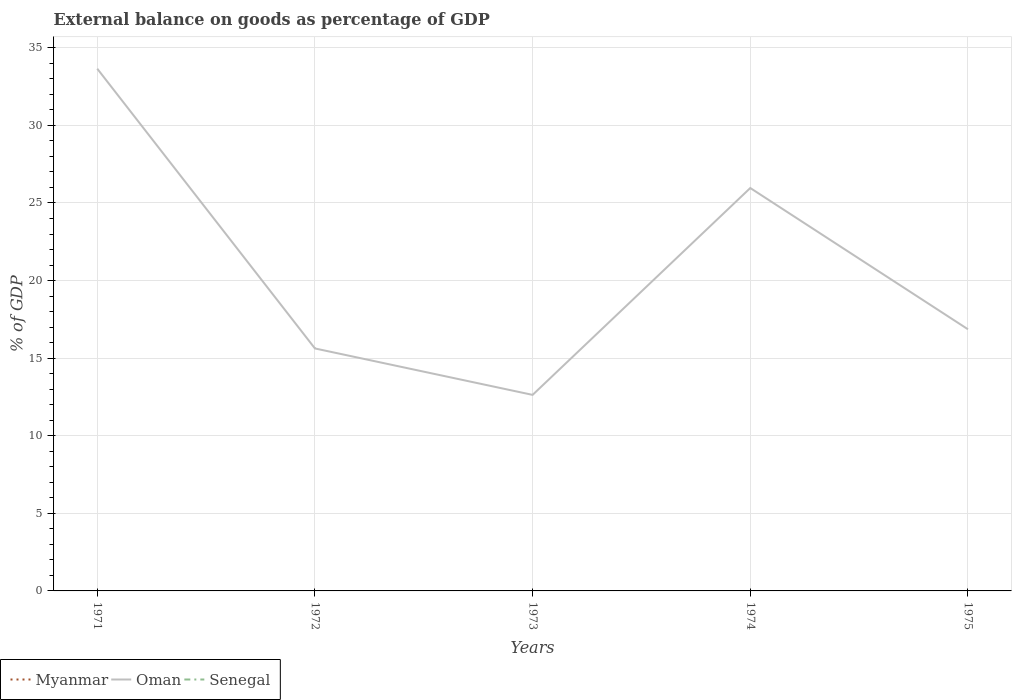How many different coloured lines are there?
Provide a succinct answer. 1. Does the line corresponding to Myanmar intersect with the line corresponding to Senegal?
Your response must be concise. No. Across all years, what is the maximum external balance on goods as percentage of GDP in Senegal?
Ensure brevity in your answer.  0. What is the total external balance on goods as percentage of GDP in Oman in the graph?
Provide a short and direct response. 21.02. What is the difference between the highest and the second highest external balance on goods as percentage of GDP in Oman?
Give a very brief answer. 21.02. What is the difference between the highest and the lowest external balance on goods as percentage of GDP in Oman?
Offer a terse response. 2. Is the external balance on goods as percentage of GDP in Oman strictly greater than the external balance on goods as percentage of GDP in Senegal over the years?
Keep it short and to the point. No. How many years are there in the graph?
Provide a short and direct response. 5. What is the difference between two consecutive major ticks on the Y-axis?
Keep it short and to the point. 5. Are the values on the major ticks of Y-axis written in scientific E-notation?
Keep it short and to the point. No. Does the graph contain any zero values?
Ensure brevity in your answer.  Yes. Does the graph contain grids?
Offer a terse response. Yes. How many legend labels are there?
Give a very brief answer. 3. How are the legend labels stacked?
Your answer should be compact. Horizontal. What is the title of the graph?
Provide a succinct answer. External balance on goods as percentage of GDP. Does "Colombia" appear as one of the legend labels in the graph?
Provide a succinct answer. No. What is the label or title of the Y-axis?
Give a very brief answer. % of GDP. What is the % of GDP of Myanmar in 1971?
Provide a succinct answer. 0. What is the % of GDP in Oman in 1971?
Provide a succinct answer. 33.65. What is the % of GDP of Oman in 1972?
Your response must be concise. 15.62. What is the % of GDP of Senegal in 1972?
Ensure brevity in your answer.  0. What is the % of GDP in Oman in 1973?
Your response must be concise. 12.63. What is the % of GDP of Oman in 1974?
Ensure brevity in your answer.  25.96. What is the % of GDP in Senegal in 1974?
Offer a very short reply. 0. What is the % of GDP in Myanmar in 1975?
Ensure brevity in your answer.  0. What is the % of GDP in Oman in 1975?
Ensure brevity in your answer.  16.86. What is the % of GDP of Senegal in 1975?
Offer a terse response. 0. Across all years, what is the maximum % of GDP in Oman?
Your response must be concise. 33.65. Across all years, what is the minimum % of GDP of Oman?
Offer a terse response. 12.63. What is the total % of GDP in Myanmar in the graph?
Provide a short and direct response. 0. What is the total % of GDP of Oman in the graph?
Offer a very short reply. 104.73. What is the total % of GDP of Senegal in the graph?
Provide a short and direct response. 0. What is the difference between the % of GDP of Oman in 1971 and that in 1972?
Your response must be concise. 18.03. What is the difference between the % of GDP in Oman in 1971 and that in 1973?
Make the answer very short. 21.02. What is the difference between the % of GDP of Oman in 1971 and that in 1974?
Provide a short and direct response. 7.69. What is the difference between the % of GDP of Oman in 1971 and that in 1975?
Keep it short and to the point. 16.79. What is the difference between the % of GDP of Oman in 1972 and that in 1973?
Provide a succinct answer. 2.99. What is the difference between the % of GDP of Oman in 1972 and that in 1974?
Offer a very short reply. -10.34. What is the difference between the % of GDP of Oman in 1972 and that in 1975?
Offer a terse response. -1.23. What is the difference between the % of GDP of Oman in 1973 and that in 1974?
Ensure brevity in your answer.  -13.33. What is the difference between the % of GDP in Oman in 1973 and that in 1975?
Offer a very short reply. -4.23. What is the difference between the % of GDP of Oman in 1974 and that in 1975?
Provide a succinct answer. 9.1. What is the average % of GDP in Oman per year?
Provide a short and direct response. 20.95. What is the average % of GDP in Senegal per year?
Make the answer very short. 0. What is the ratio of the % of GDP of Oman in 1971 to that in 1972?
Provide a short and direct response. 2.15. What is the ratio of the % of GDP in Oman in 1971 to that in 1973?
Offer a very short reply. 2.66. What is the ratio of the % of GDP of Oman in 1971 to that in 1974?
Provide a short and direct response. 1.3. What is the ratio of the % of GDP of Oman in 1971 to that in 1975?
Provide a short and direct response. 2. What is the ratio of the % of GDP of Oman in 1972 to that in 1973?
Offer a very short reply. 1.24. What is the ratio of the % of GDP of Oman in 1972 to that in 1974?
Offer a terse response. 0.6. What is the ratio of the % of GDP of Oman in 1972 to that in 1975?
Offer a very short reply. 0.93. What is the ratio of the % of GDP in Oman in 1973 to that in 1974?
Your response must be concise. 0.49. What is the ratio of the % of GDP of Oman in 1973 to that in 1975?
Keep it short and to the point. 0.75. What is the ratio of the % of GDP of Oman in 1974 to that in 1975?
Make the answer very short. 1.54. What is the difference between the highest and the second highest % of GDP in Oman?
Offer a terse response. 7.69. What is the difference between the highest and the lowest % of GDP of Oman?
Provide a short and direct response. 21.02. 